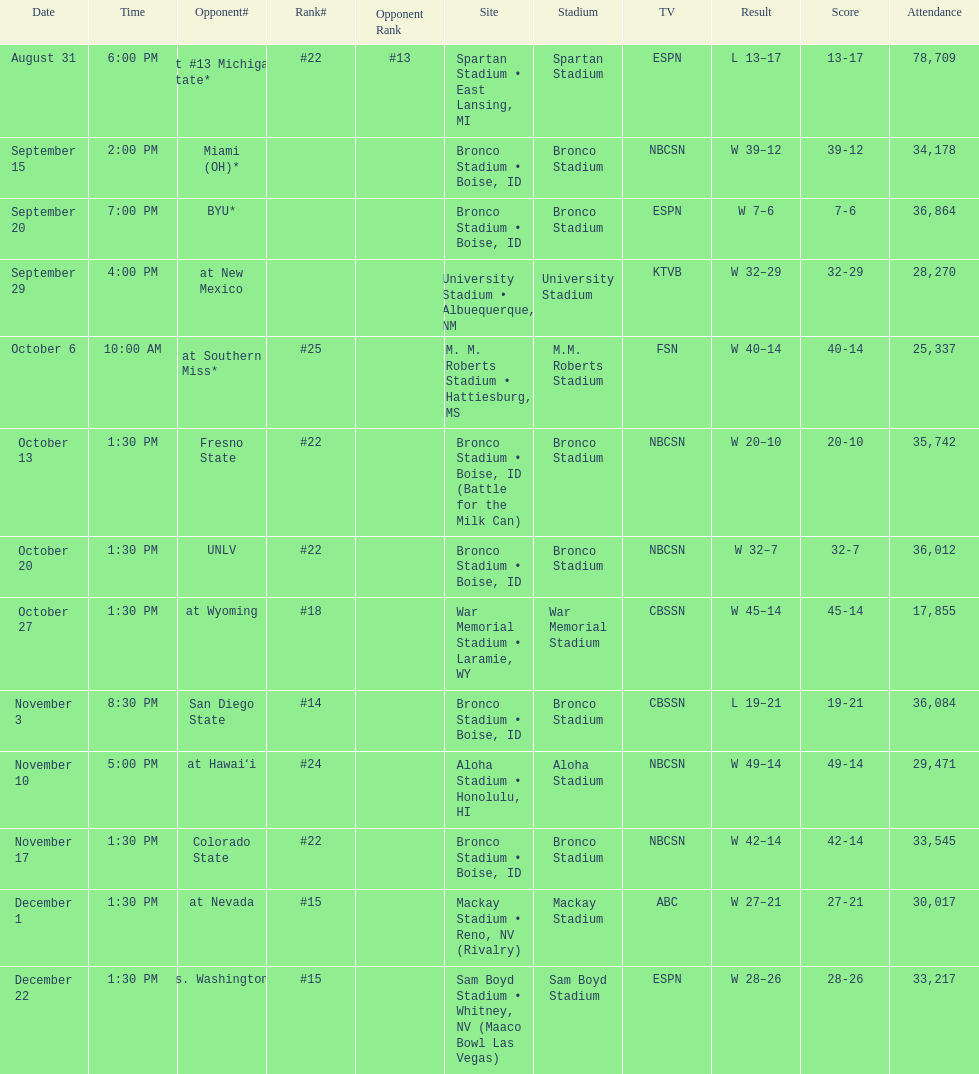Number of points scored by miami (oh) against the broncos. 12. 